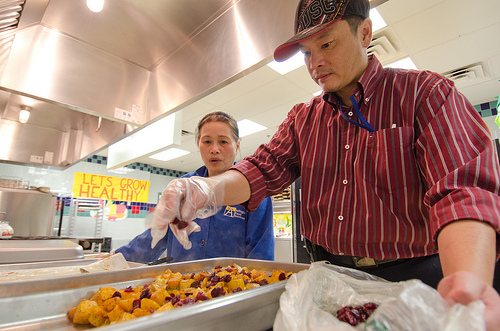<image>
Is the glove above the food? Yes. The glove is positioned above the food in the vertical space, higher up in the scene. 